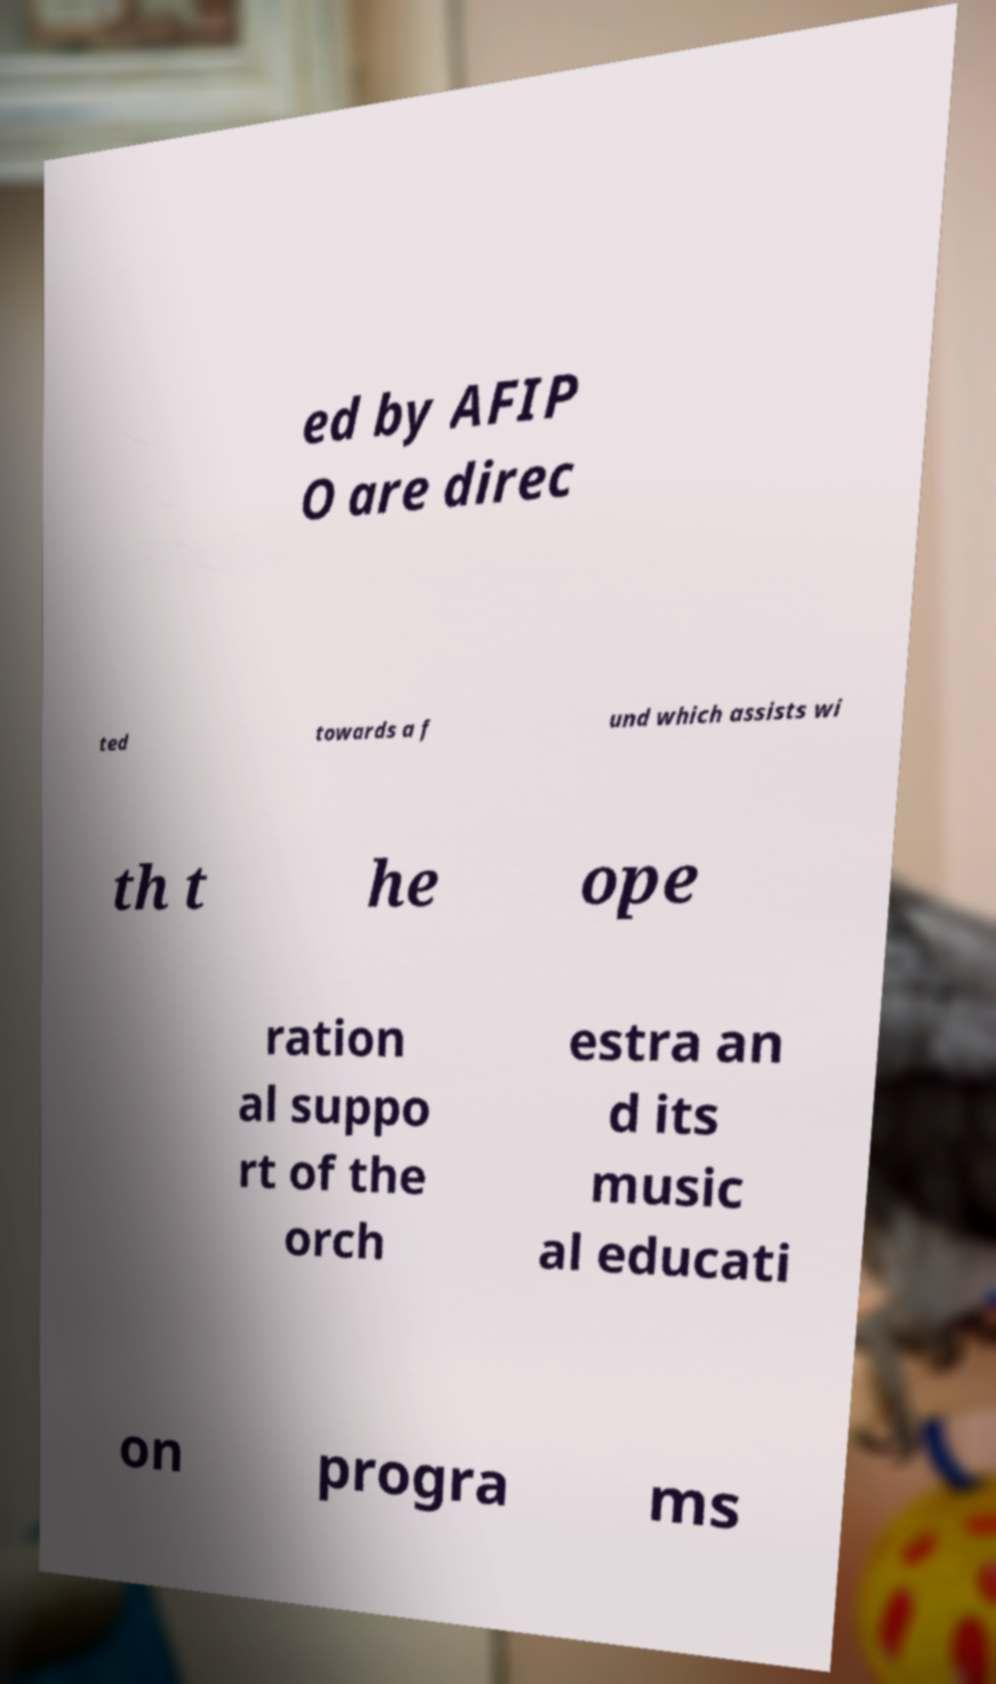Can you accurately transcribe the text from the provided image for me? ed by AFIP O are direc ted towards a f und which assists wi th t he ope ration al suppo rt of the orch estra an d its music al educati on progra ms 